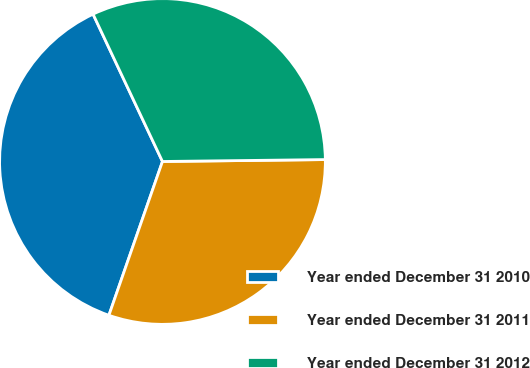<chart> <loc_0><loc_0><loc_500><loc_500><pie_chart><fcel>Year ended December 31 2010<fcel>Year ended December 31 2011<fcel>Year ended December 31 2012<nl><fcel>37.66%<fcel>30.52%<fcel>31.82%<nl></chart> 